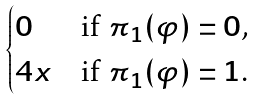<formula> <loc_0><loc_0><loc_500><loc_500>\begin{cases} 0 & \text {if $\pi_{1}(\varphi)=0$,} \\ 4 x & \text {if $\pi_{1}(\varphi)=1$.} \end{cases}</formula> 